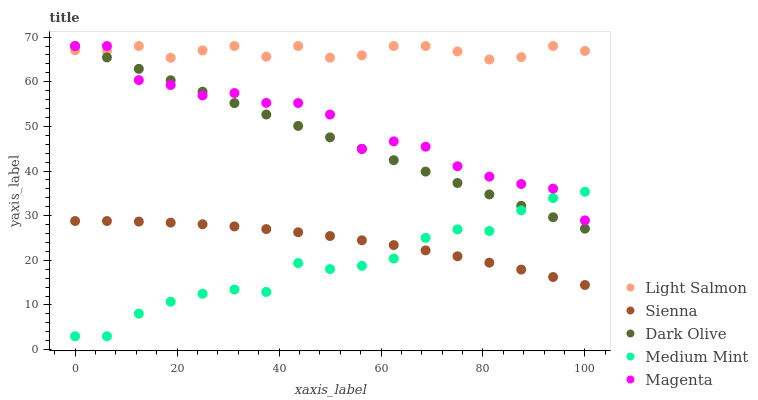Does Medium Mint have the minimum area under the curve?
Answer yes or no. Yes. Does Light Salmon have the maximum area under the curve?
Answer yes or no. Yes. Does Light Salmon have the minimum area under the curve?
Answer yes or no. No. Does Medium Mint have the maximum area under the curve?
Answer yes or no. No. Is Dark Olive the smoothest?
Answer yes or no. Yes. Is Magenta the roughest?
Answer yes or no. Yes. Is Medium Mint the smoothest?
Answer yes or no. No. Is Medium Mint the roughest?
Answer yes or no. No. Does Medium Mint have the lowest value?
Answer yes or no. Yes. Does Light Salmon have the lowest value?
Answer yes or no. No. Does Magenta have the highest value?
Answer yes or no. Yes. Does Medium Mint have the highest value?
Answer yes or no. No. Is Sienna less than Light Salmon?
Answer yes or no. Yes. Is Light Salmon greater than Sienna?
Answer yes or no. Yes. Does Light Salmon intersect Dark Olive?
Answer yes or no. Yes. Is Light Salmon less than Dark Olive?
Answer yes or no. No. Is Light Salmon greater than Dark Olive?
Answer yes or no. No. Does Sienna intersect Light Salmon?
Answer yes or no. No. 